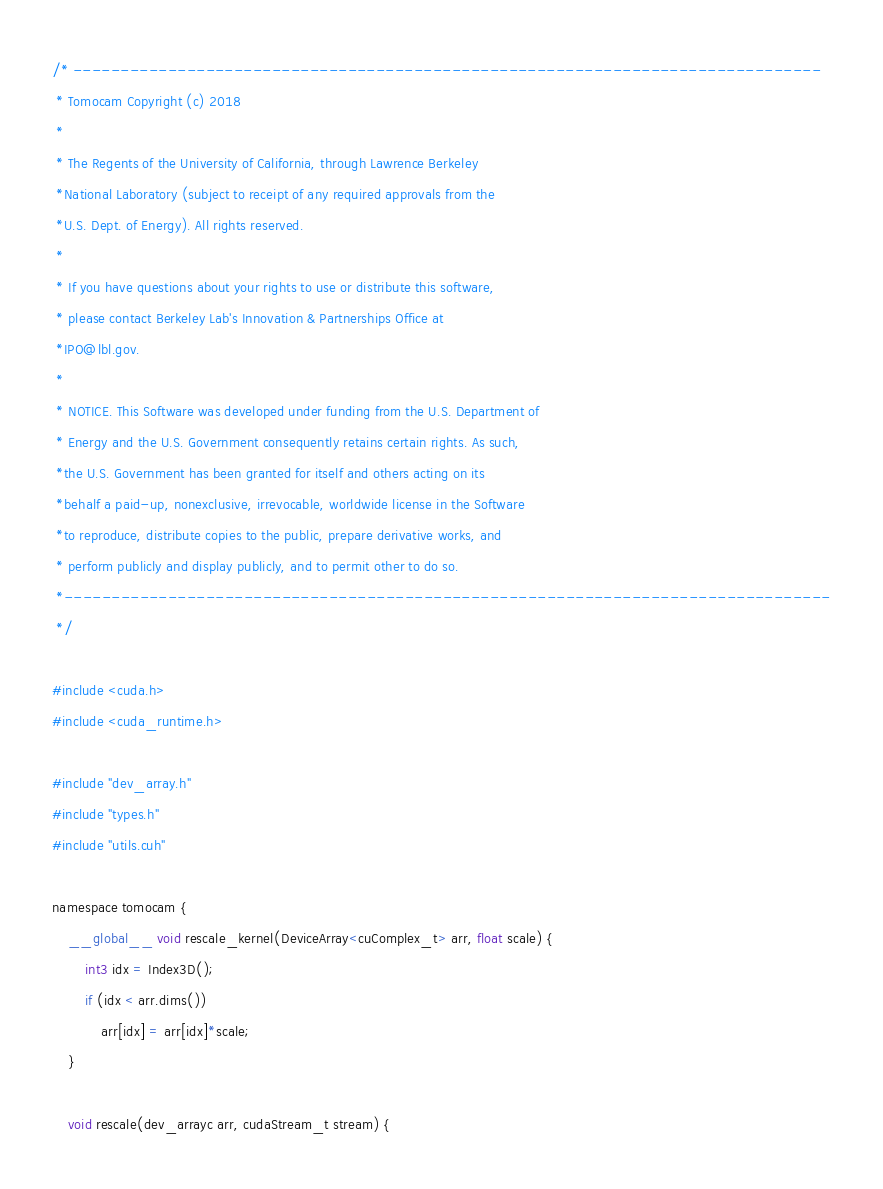Convert code to text. <code><loc_0><loc_0><loc_500><loc_500><_Cuda_>/* -------------------------------------------------------------------------------
 * Tomocam Copyright (c) 2018
 *
 * The Regents of the University of California, through Lawrence Berkeley
 *National Laboratory (subject to receipt of any required approvals from the
 *U.S. Dept. of Energy). All rights reserved.
 *
 * If you have questions about your rights to use or distribute this software,
 * please contact Berkeley Lab's Innovation & Partnerships Office at
 *IPO@lbl.gov.
 *
 * NOTICE. This Software was developed under funding from the U.S. Department of
 * Energy and the U.S. Government consequently retains certain rights. As such,
 *the U.S. Government has been granted for itself and others acting on its
 *behalf a paid-up, nonexclusive, irrevocable, worldwide license in the Software
 *to reproduce, distribute copies to the public, prepare derivative works, and
 * perform publicly and display publicly, and to permit other to do so.
 *---------------------------------------------------------------------------------
 */

#include <cuda.h>
#include <cuda_runtime.h>

#include "dev_array.h"
#include "types.h"
#include "utils.cuh"

namespace tomocam {
    __global__ void rescale_kernel(DeviceArray<cuComplex_t> arr, float scale) {
        int3 idx = Index3D();
        if (idx < arr.dims()) 
            arr[idx] = arr[idx]*scale;
    }

    void rescale(dev_arrayc arr, cudaStream_t stream) {</code> 